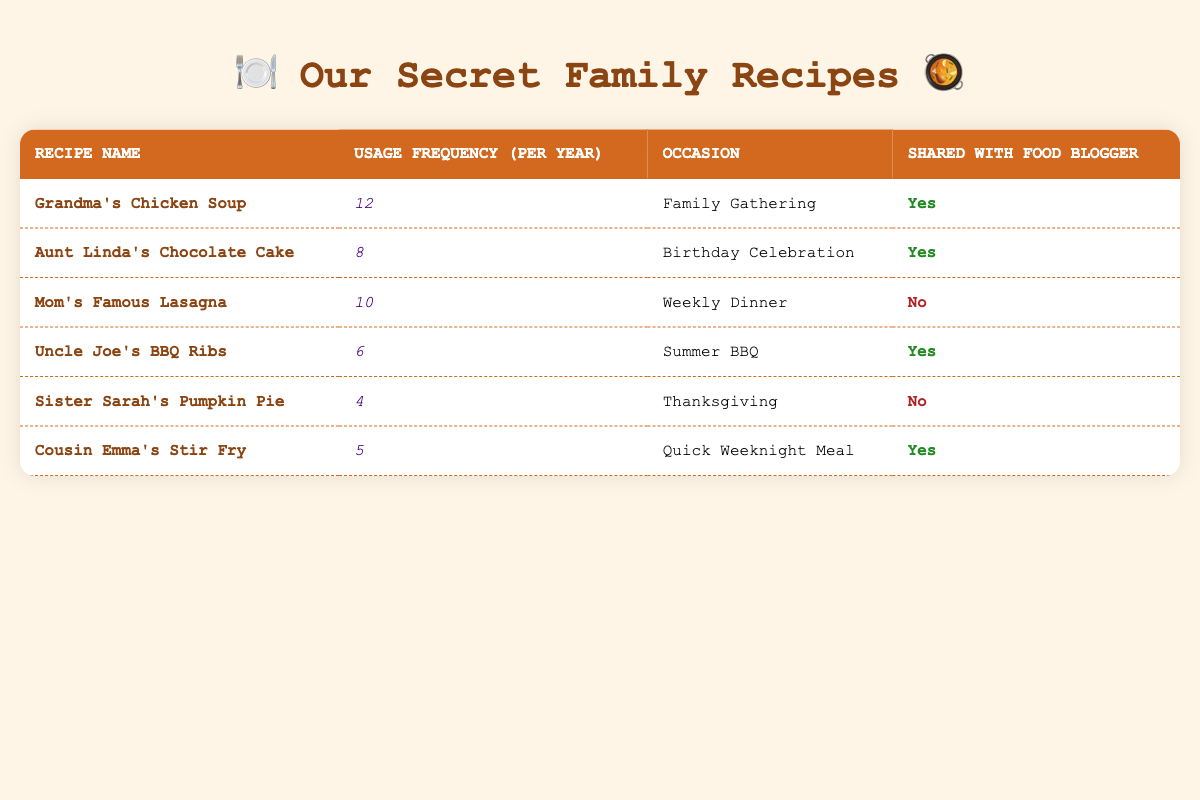What is the usage frequency of Aunt Linda's Chocolate Cake? Looking at the table, Aunt Linda's Chocolate Cake has a usage frequency of 8, as indicated in the corresponding row.
Answer: 8 Which recipe has the highest usage frequency? By examining the usage frequency column, Grandma's Chicken Soup has the highest frequency at 12, which is greater than any other recipe listed.
Answer: Grandma's Chicken Soup How many recipes are shared with the food blogger? Counting the entries in the "Shared with Food Blogger" column, four recipes (Grandma's Chicken Soup, Aunt Linda's Chocolate Cake, Uncle Joe's BBQ Ribs, Cousin Emma's Stir Fry) indicate "Yes," demonstrating they are shared.
Answer: 4 What is the total usage frequency of recipes that are not shared with the food blogger? The not shared recipes are Mom's Famous Lasagna (10) and Sister Sarah's Pumpkin Pie (4). Summing these, we get 10 + 4 = 14.
Answer: 14 Is Sister Sarah's Pumpkin Pie shared with the food blogger? The table states that Sister Sarah's Pumpkin Pie is marked "No" in the "Shared with Food Blogger" column, indicating it is not shared.
Answer: No On which occasion is Uncle Joe's BBQ Ribs typically used? Referring to the table, Uncle Joe's BBQ Ribs are used for Summer BBQ, as seen in the respective row.
Answer: Summer BBQ What is the average usage frequency of all recipes in the table? The total usage frequencies are 12, 8, 10, 6, 4, and 5. Adding these gives 45. Since there are 6 recipes, the average is calculated as 45/6 = 7.5.
Answer: 7.5 Which recipe is used the least frequently and how often? In the usage frequency column, Sister Sarah's Pumpkin Pie with a frequency of 4 is identified as the recipe with the least usage compared to the others.
Answer: Sister Sarah's Pumpkin Pie, 4 Are Mom's Famous Lasagna and Cousin Emma's Stir Fry used on the same occasion? Mom's Famous Lasagna is used for Weekly Dinner, while Cousin Emma's Stir Fry is for Quick Weeknight Meal, so they are used on different occasions.
Answer: No 